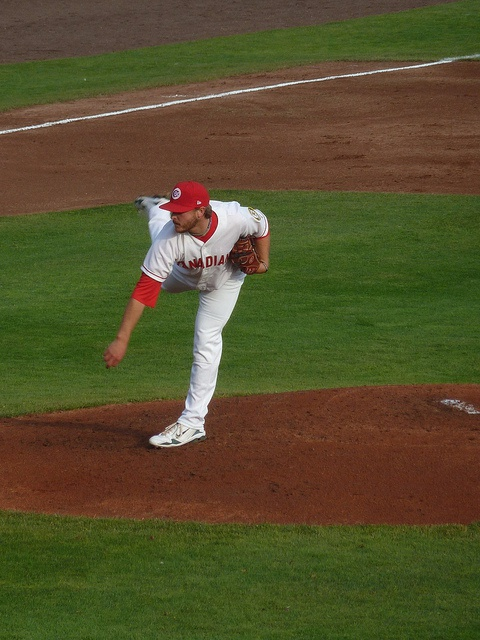Describe the objects in this image and their specific colors. I can see people in black, lightgray, darkgray, darkgreen, and maroon tones and baseball glove in black, maroon, and brown tones in this image. 